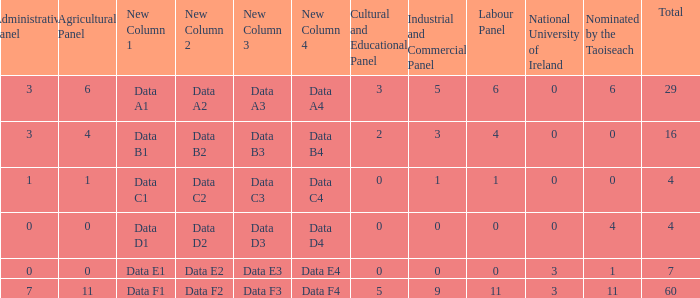What is the average administrative panel of the composition nominated by Taoiseach 0 times with a total less than 4? None. 